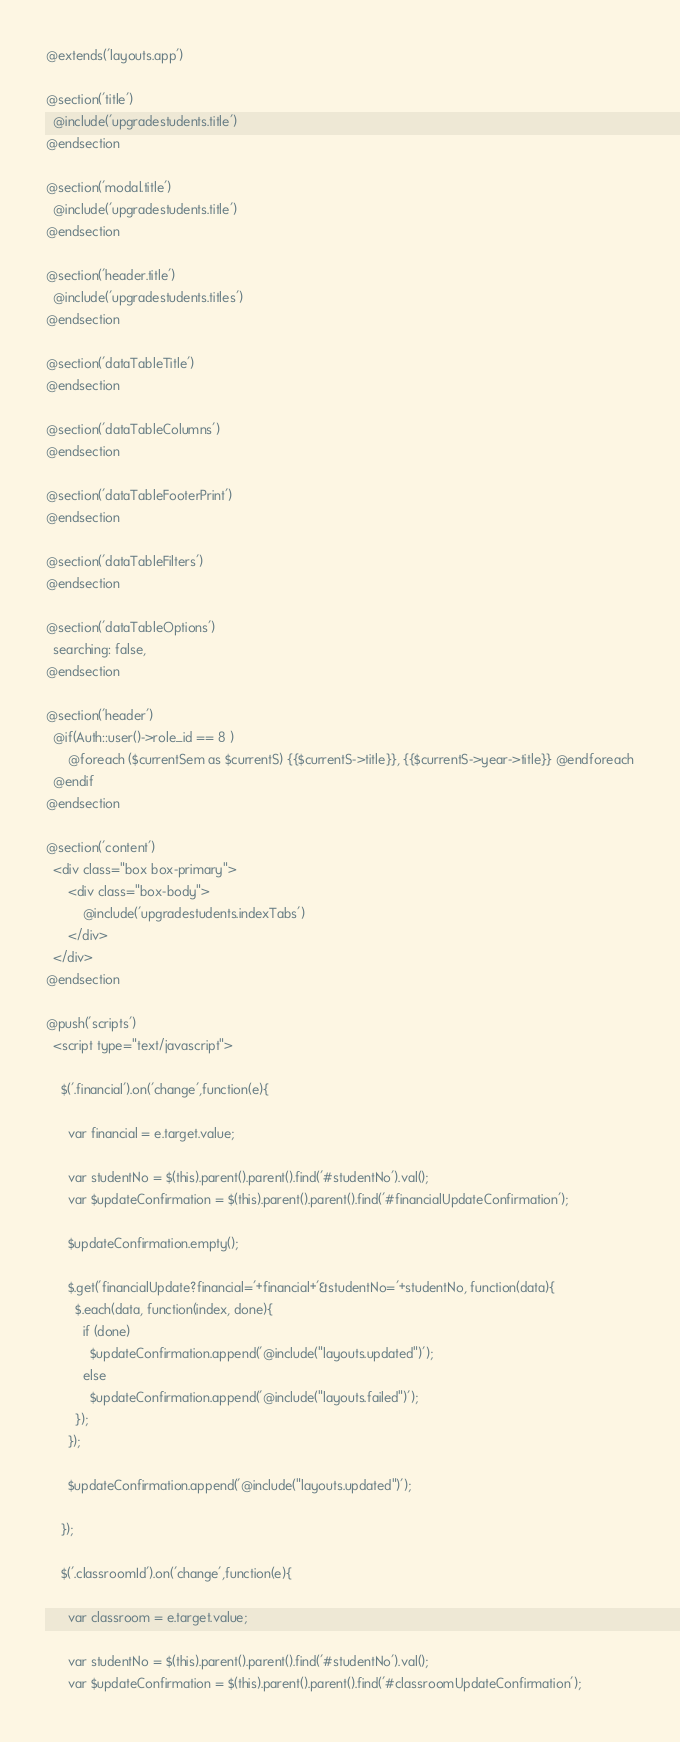<code> <loc_0><loc_0><loc_500><loc_500><_PHP_>@extends('layouts.app')

@section('title')
  @include('upgradestudents.title')
@endsection

@section('modal.title')
  @include('upgradestudents.title')
@endsection

@section('header.title')
  @include('upgradestudents.titles')
@endsection

@section('dataTableTitle')
@endsection

@section('dataTableColumns')
@endsection

@section('dataTableFooterPrint')
@endsection

@section('dataTableFilters')
@endsection

@section('dataTableOptions')
  searching: false,
@endsection

@section('header')
  @if(Auth::user()->role_id == 8 )
      @foreach ($currentSem as $currentS) {{$currentS->title}}, {{$currentS->year->title}} @endforeach
  @endif
@endsection

@section('content')
  <div class="box box-primary">
      <div class="box-body">
          @include('upgradestudents.indexTabs')
      </div>
  </div>
@endsection

@push('scripts') 
  <script type="text/javascript">

    $('.financial').on('change',function(e){

      var financial = e.target.value;

      var studentNo = $(this).parent().parent().find('#studentNo').val();
      var $updateConfirmation = $(this).parent().parent().find('#financialUpdateConfirmation');

      $updateConfirmation.empty();

      $.get('financialUpdate?financial='+financial+'&studentNo='+studentNo, function(data){
        $.each(data, function(index, done){
          if (done)
            $updateConfirmation.append('@include("layouts.updated")');
          else
            $updateConfirmation.append('@include("layouts.failed")');
        });
      });
      
      $updateConfirmation.append('@include("layouts.updated")');

    });

    $('.classroomId').on('change',function(e){

      var classroom = e.target.value;

      var studentNo = $(this).parent().parent().find('#studentNo').val();
      var $updateConfirmation = $(this).parent().parent().find('#classroomUpdateConfirmation');
</code> 